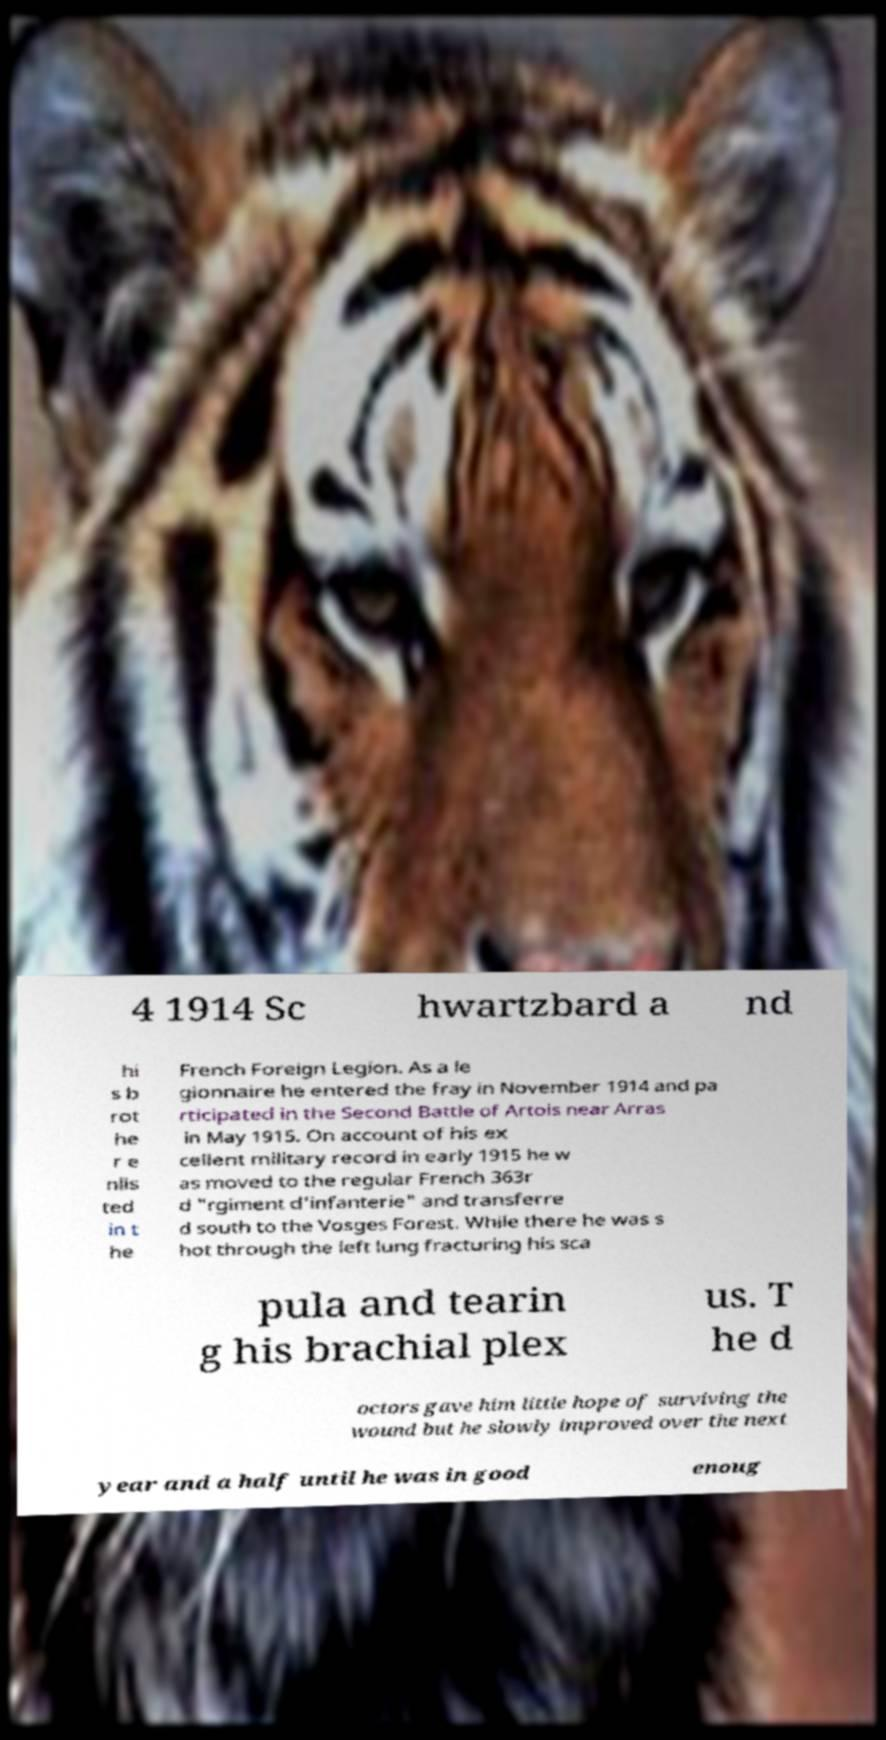Please read and relay the text visible in this image. What does it say? 4 1914 Sc hwartzbard a nd hi s b rot he r e nlis ted in t he French Foreign Legion. As a le gionnaire he entered the fray in November 1914 and pa rticipated in the Second Battle of Artois near Arras in May 1915. On account of his ex cellent military record in early 1915 he w as moved to the regular French 363r d "rgiment d’infanterie" and transferre d south to the Vosges Forest. While there he was s hot through the left lung fracturing his sca pula and tearin g his brachial plex us. T he d octors gave him little hope of surviving the wound but he slowly improved over the next year and a half until he was in good enoug 